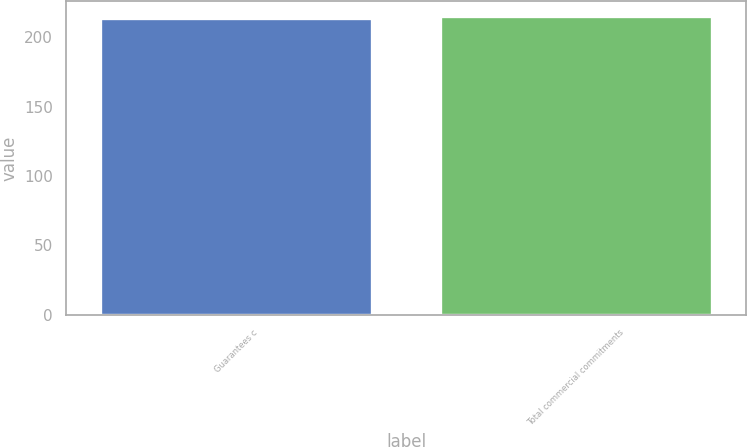Convert chart. <chart><loc_0><loc_0><loc_500><loc_500><bar_chart><fcel>Guarantees c<fcel>Total commercial commitments<nl><fcel>214<fcel>215<nl></chart> 